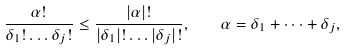<formula> <loc_0><loc_0><loc_500><loc_500>\frac { \alpha ! } { \delta _ { 1 } ! \dots \delta _ { j } ! } \leq \frac { | \alpha | ! } { | \delta _ { 1 } | ! \dots | \delta _ { j } | ! } , \quad \alpha = \delta _ { 1 } + \dots + \delta _ { j } ,</formula> 